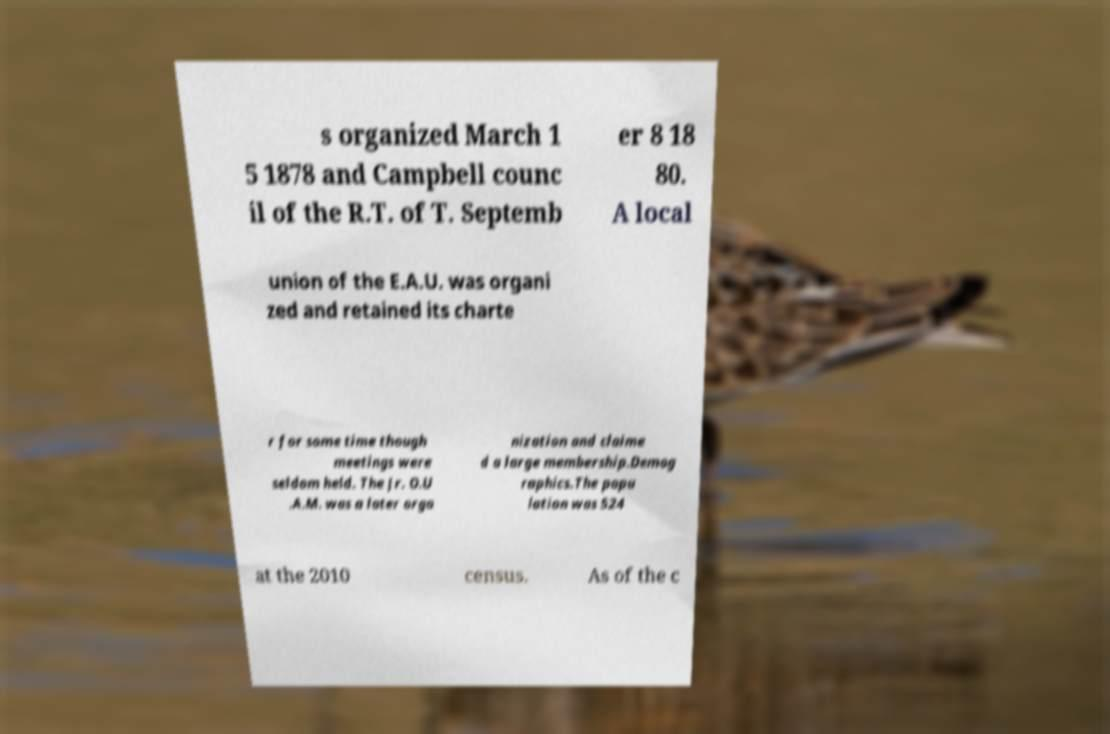There's text embedded in this image that I need extracted. Can you transcribe it verbatim? s organized March 1 5 1878 and Campbell counc il of the R.T. of T. Septemb er 8 18 80. A local union of the E.A.U. was organi zed and retained its charte r for some time though meetings were seldom held. The Jr. O.U .A.M. was a later orga nization and claime d a large membership.Demog raphics.The popu lation was 524 at the 2010 census. As of the c 